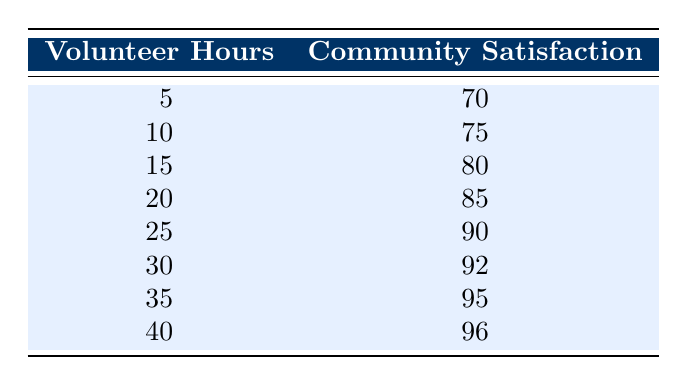What is the community satisfaction level when the volunteer hours are 5? The table shows a direct correlation between volunteer hours and community satisfaction. According to the data, when volunteer hours are 5, the community satisfaction level is listed directly next to it as 70.
Answer: 70 What is the maximum community satisfaction level recorded in this table? To determine the maximum community satisfaction, we can look at the last entry in the table, which shows that with 40 volunteer hours, the community satisfaction level is 96.
Answer: 96 What is the difference in community satisfaction between 30 and 20 volunteer hours? From the table, the community satisfaction level for 30 volunteer hours is 92, and for 20 volunteer hours, it is 85. The difference is calculated as 92 - 85 = 7.
Answer: 7 Is the community satisfaction level greater than 90 for all volunteer hours above 25? From the table, community satisfaction levels for 30 hours (92), 35 hours (95), and 40 hours (96) are indeed all greater than 90. Therefore, the statement is true.
Answer: Yes What is the average community satisfaction level for volunteer hours between 10 and 30? We take the community satisfaction values for volunteer hours 10 (75), 15 (80), 20 (85), 25 (90), and 30 (92). The sum is 75 + 80 + 85 + 90 + 92 = 422. There are 5 entries, so the average is 422 / 5 = 84.4.
Answer: 84.4 What community satisfaction level corresponds to 35 volunteer hours? Referring directly to the table, when volunteer hours are 35, the community satisfaction level is stated to be 95.
Answer: 95 How many hours of volunteer work are needed to achieve a community satisfaction level of at least 80? Looking at the table, the community satisfaction level reaches 80 at 15 volunteer hours and continues to increase with higher hours. Therefore, 15 hours is the minimum requirement to achieve satisfaction above 80.
Answer: 15 What is the median level of community satisfaction from the data provided? The data points in community satisfaction are 70, 75, 80, 85, 90, 92, 95, 96. As there are eight data points (an even number), the median is the average of the two middle numbers (85 and 90). Calculating gives (85 + 90) / 2 = 87.5.
Answer: 87.5 